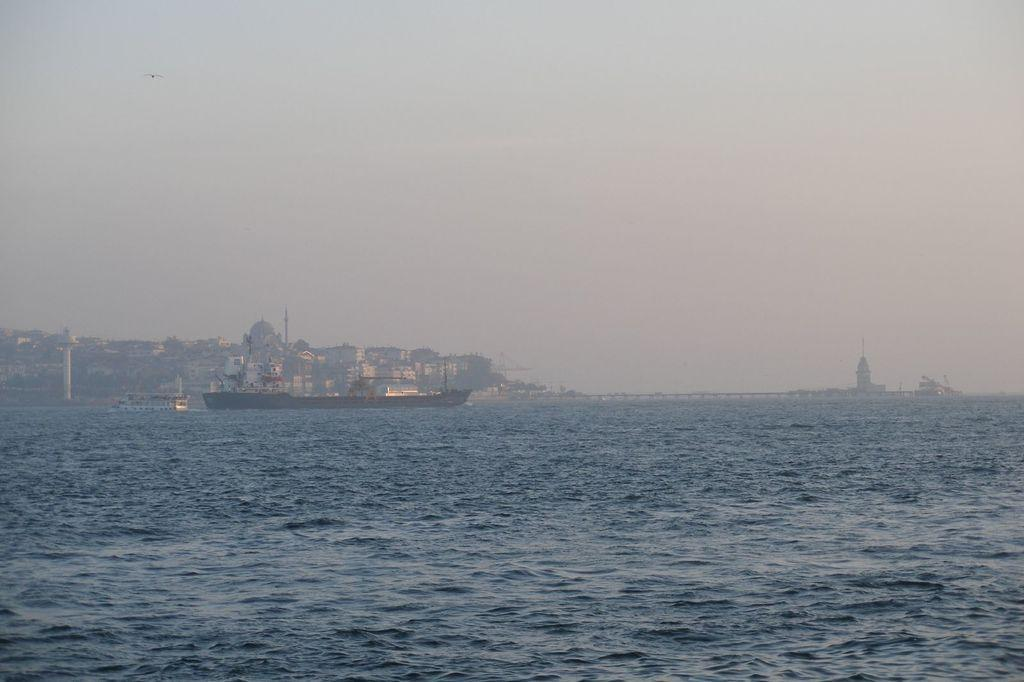What is on the water in the image? There are ships on the water in the image. What can be seen in the background of the image? There are buildings and the sky visible in the background of the image. How does the steam from the ships affect the wound on the person's arm in the image? There is no person or wound present in the image; it features ships on the water and buildings in the background. 